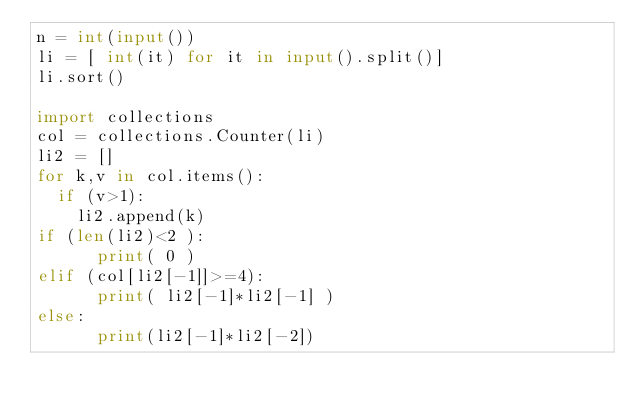Convert code to text. <code><loc_0><loc_0><loc_500><loc_500><_Python_>n = int(input())
li = [ int(it) for it in input().split()]
li.sort()

import collections
col = collections.Counter(li)
li2 = []
for k,v in col.items():
  if (v>1):
    li2.append(k)
if (len(li2)<2 ):
      print( 0 )      
elif (col[li2[-1]]>=4):
      print( li2[-1]*li2[-1] )
else:
      print(li2[-1]*li2[-2])</code> 